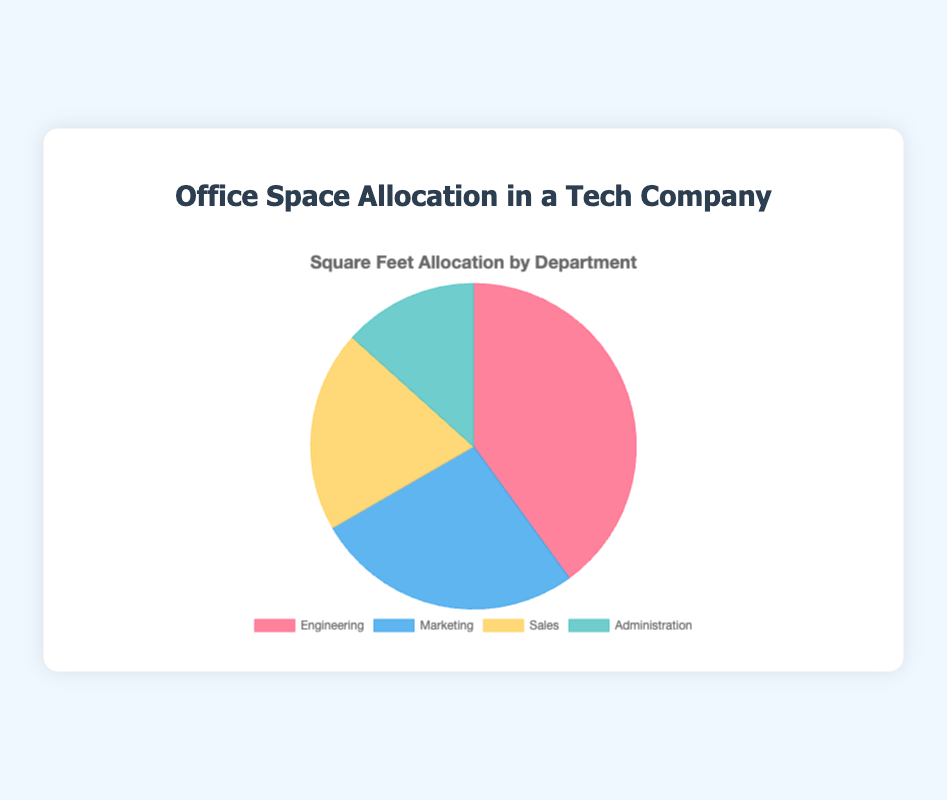What is the total square footage allocated to all departments? The total square footage can be found by summing up the square footage of all departments: 3000 (Engineering) + 2000 (Marketing) + 1500 (Sales) + 1000 (Administration) = 7500 sq ft.
Answer: 7500 sq ft Which department has the largest allocation of office space? By comparing the values for all departments, Engineering has the largest allocation with 3000 square feet.
Answer: Engineering What percentage of the total office space is allocated to the Marketing department? First, calculate the total square footage: 7500 sq ft. Then, divide Marketing's square footage by the total and multiply by 100: (2000 / 7500) * 100 ≈ 26.67%.
Answer: ~26.67% How much more office space is allocated to Engineering compared to Administration? Subtract the square footage of Administration from Engineering: 3000 (Engineering) - 1000 (Administration) = 2000 sq ft.
Answer: 2000 sq ft Is the sum of the office space allocated to Sales and Administration greater than that of Marketing? Sum the square footage of Sales and Administration: 1500 (Sales) + 1000 (Administration) = 2500 sq ft. Compare this to Marketing's allocation of 2000 sq ft. Since 2500 sq ft > 2000 sq ft, the sum is greater.
Answer: Yes What is the ratio of the office space allocated to Engineering to the office space allocated to Sales? Divide the square footage of Engineering by Sales: 3000 / 1500 = 2. The ratio is 2:1.
Answer: 2:1 Which department has the smallest allocation of office space, and what is its percentage of the total space? Administration has the smallest allocation with 1000 sq ft. To find the percentage, divide 1000 by 7500 and multiply by 100: (1000 / 7500) * 100 ≈ 13.33%.
Answer: Administration, ~13.33% If the company decides to increase the office space allocated to Marketing by 500 sq ft, what will be the new percentage of the total office space for Marketing? First, calculate the new total square footage: 7500 + 500 = 8000 sq ft. Then, calculate the new Marketing space: 2000 + 500 = 2500 sq ft. Divide the new Marketing space by the new total and multiply by 100: (2500 / 8000) * 100 = 31.25%.
Answer: 31.25% What is the combined percentage of office space for Engineering and Sales departments? First, sum the square footage of Engineering and Sales: 3000 + 1500 = 4500 sq ft. Then, divide this by the total square footage and multiply by 100: (4500 / 7500) * 100 = 60%.
Answer: 60% What is the difference in the percentage of office space allocation between the Marketing and Sales departments? Calculate the percentage for each: Marketing = (2000 / 7500) * 100 = 26.67%, Sales = (1500 / 7500) * 100 = 20%. The difference is 26.67% - 20% = 6.67%.
Answer: 6.67% 